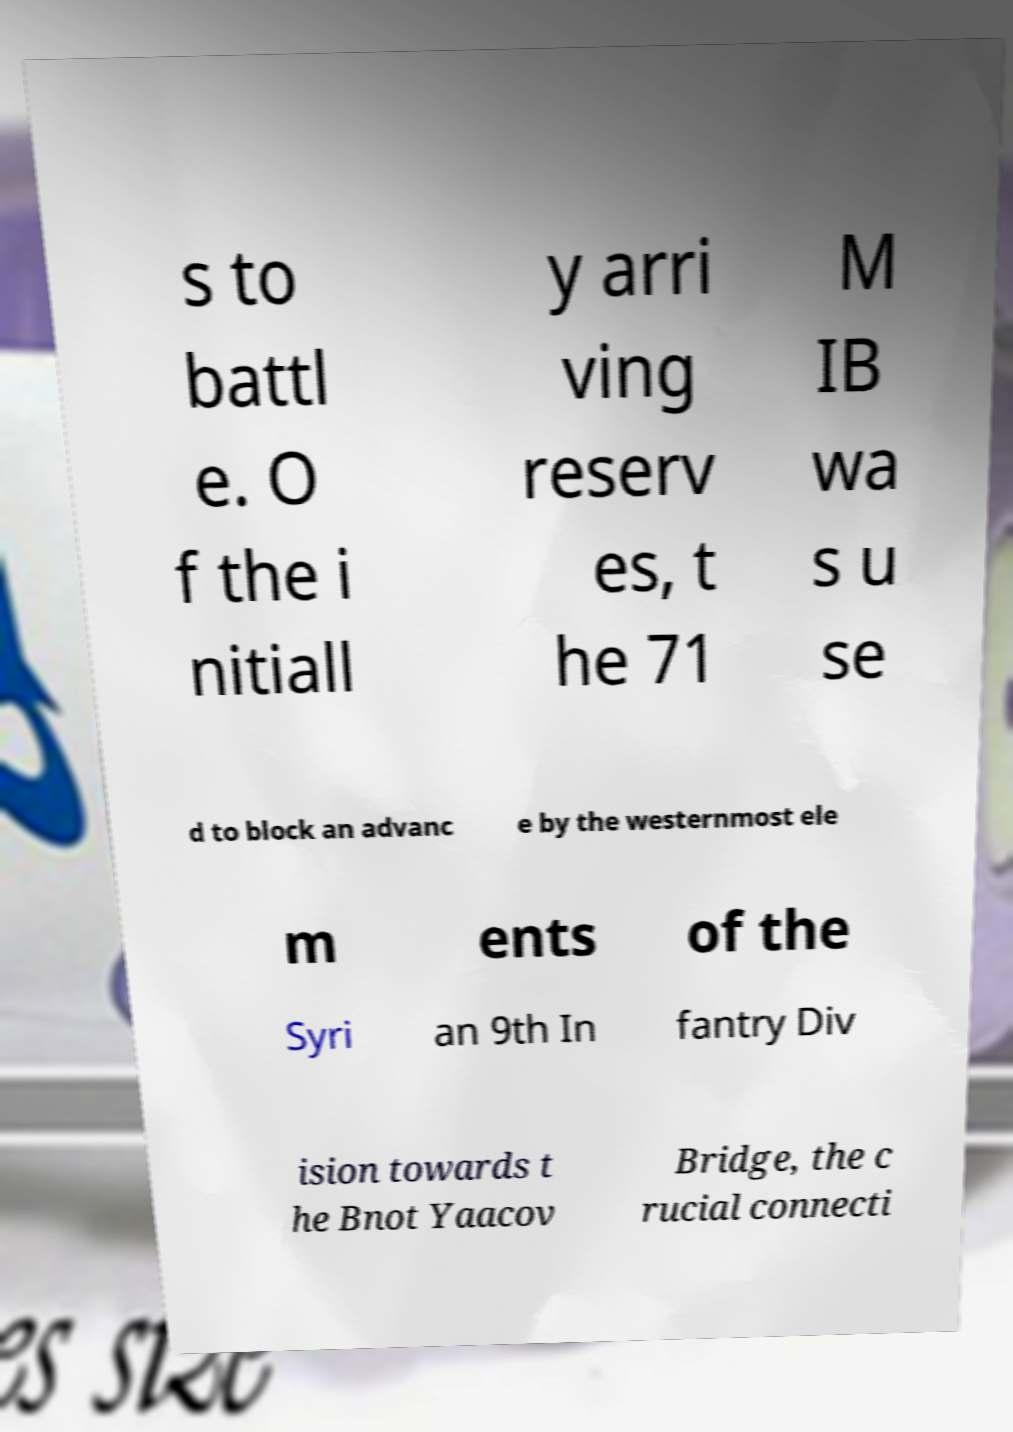Could you assist in decoding the text presented in this image and type it out clearly? s to battl e. O f the i nitiall y arri ving reserv es, t he 71 M IB wa s u se d to block an advanc e by the westernmost ele m ents of the Syri an 9th In fantry Div ision towards t he Bnot Yaacov Bridge, the c rucial connecti 